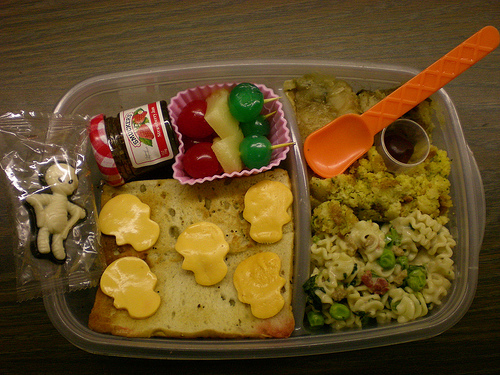<image>
Can you confirm if the plate is under the food? Yes. The plate is positioned underneath the food, with the food above it in the vertical space. Where is the spoon in relation to the bowl? Is it in the bowl? Yes. The spoon is contained within or inside the bowl, showing a containment relationship. Is the food in the box? Yes. The food is contained within or inside the box, showing a containment relationship. 